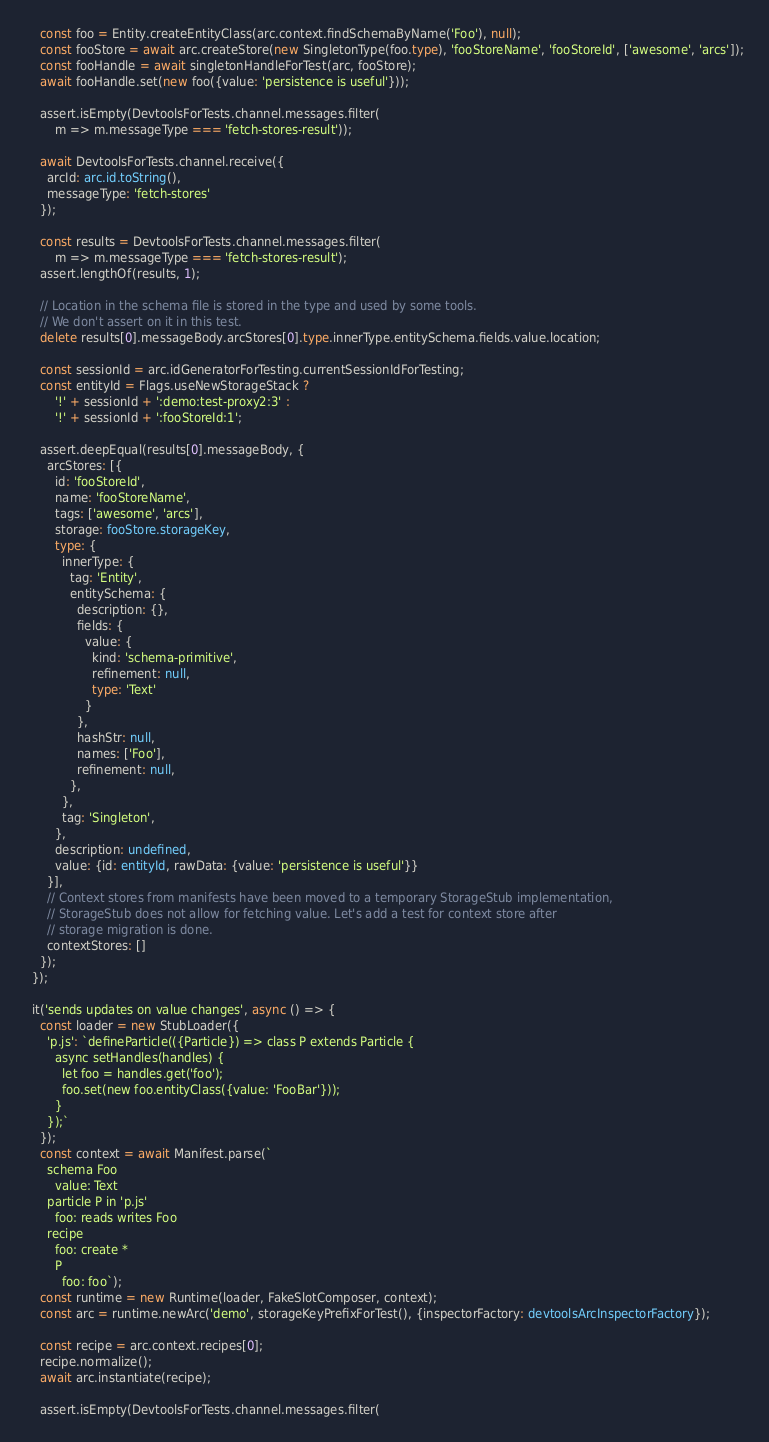Convert code to text. <code><loc_0><loc_0><loc_500><loc_500><_TypeScript_>
    const foo = Entity.createEntityClass(arc.context.findSchemaByName('Foo'), null);
    const fooStore = await arc.createStore(new SingletonType(foo.type), 'fooStoreName', 'fooStoreId', ['awesome', 'arcs']);
    const fooHandle = await singletonHandleForTest(arc, fooStore);
    await fooHandle.set(new foo({value: 'persistence is useful'}));

    assert.isEmpty(DevtoolsForTests.channel.messages.filter(
        m => m.messageType === 'fetch-stores-result'));

    await DevtoolsForTests.channel.receive({
      arcId: arc.id.toString(),
      messageType: 'fetch-stores'
    });

    const results = DevtoolsForTests.channel.messages.filter(
        m => m.messageType === 'fetch-stores-result');
    assert.lengthOf(results, 1);

    // Location in the schema file is stored in the type and used by some tools.
    // We don't assert on it in this test.
    delete results[0].messageBody.arcStores[0].type.innerType.entitySchema.fields.value.location;

    const sessionId = arc.idGeneratorForTesting.currentSessionIdForTesting;
    const entityId = Flags.useNewStorageStack ?
        '!' + sessionId + ':demo:test-proxy2:3' :
        '!' + sessionId + ':fooStoreId:1';

    assert.deepEqual(results[0].messageBody, {
      arcStores: [{
        id: 'fooStoreId',
        name: 'fooStoreName',
        tags: ['awesome', 'arcs'],
        storage: fooStore.storageKey,
        type: {
          innerType: {
            tag: 'Entity',
            entitySchema: {
              description: {},
              fields: {
                value: {
                  kind: 'schema-primitive',
                  refinement: null,
                  type: 'Text'
                }
              },
              hashStr: null,
              names: ['Foo'],
              refinement: null,
            },
          },
          tag: 'Singleton',
        },
        description: undefined,
        value: {id: entityId, rawData: {value: 'persistence is useful'}}
      }],
      // Context stores from manifests have been moved to a temporary StorageStub implementation,
      // StorageStub does not allow for fetching value. Let's add a test for context store after
      // storage migration is done.
      contextStores: []
    });
  });

  it('sends updates on value changes', async () => {
    const loader = new StubLoader({
      'p.js': `defineParticle(({Particle}) => class P extends Particle {
        async setHandles(handles) {
          let foo = handles.get('foo');
          foo.set(new foo.entityClass({value: 'FooBar'}));
        }
      });`
    });
    const context = await Manifest.parse(`
      schema Foo
        value: Text
      particle P in 'p.js'
        foo: reads writes Foo
      recipe
        foo: create *
        P
          foo: foo`);
    const runtime = new Runtime(loader, FakeSlotComposer, context);
    const arc = runtime.newArc('demo', storageKeyPrefixForTest(), {inspectorFactory: devtoolsArcInspectorFactory});

    const recipe = arc.context.recipes[0];
    recipe.normalize();
    await arc.instantiate(recipe);

    assert.isEmpty(DevtoolsForTests.channel.messages.filter(</code> 